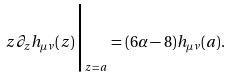Convert formula to latex. <formula><loc_0><loc_0><loc_500><loc_500>z \partial _ { z } h _ { \mu \nu } ( z ) \Big | _ { z = a } = ( 6 \alpha - 8 ) h _ { \mu \nu } ( a ) .</formula> 